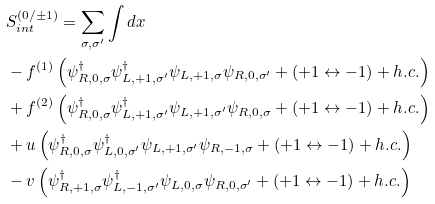Convert formula to latex. <formula><loc_0><loc_0><loc_500><loc_500>& S _ { i n t } ^ { ( 0 / \pm 1 ) } = \sum _ { \sigma , \sigma ^ { \prime } } \int d x \\ & - f ^ { ( 1 ) } \left ( \psi ^ { \dagger } _ { R , 0 , \sigma } \psi ^ { \dagger } _ { L , + 1 , \sigma ^ { \prime } } \psi _ { L , + 1 , \sigma } \psi _ { R , 0 , \sigma ^ { \prime } } + ( + 1 \leftrightarrow - 1 ) + h . c . \right ) \\ & + f ^ { ( 2 ) } \left ( \psi ^ { \dagger } _ { R , 0 , \sigma } \psi ^ { \dagger } _ { L , + 1 , \sigma ^ { \prime } } \psi _ { L , + 1 , \sigma ^ { \prime } } \psi _ { R , 0 , \sigma } + ( + 1 \leftrightarrow - 1 ) + h . c . \right ) \\ & + u \left ( \psi ^ { \dagger } _ { R , 0 , \sigma } \psi ^ { \dagger } _ { L , 0 , \sigma ^ { \prime } } \psi _ { L , + 1 , \sigma ^ { \prime } } \psi _ { R , - 1 , \sigma } + ( + 1 \leftrightarrow - 1 ) + h . c . \right ) \\ & - v \left ( \psi ^ { \dagger } _ { R , + 1 , \sigma } \psi ^ { \dagger } _ { L , - 1 , \sigma ^ { \prime } } \psi _ { L , 0 , \sigma } \psi _ { R , 0 , \sigma ^ { \prime } } + ( + 1 \leftrightarrow - 1 ) + h . c . \right )</formula> 